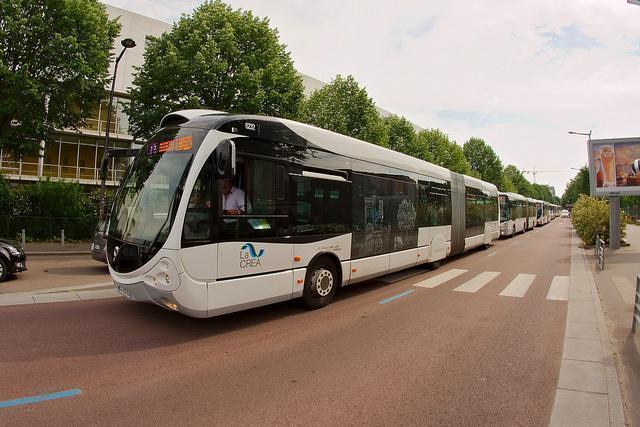What do the white markings on the road allow for here?
Answer the question by selecting the correct answer among the 4 following choices and explain your choice with a short sentence. The answer should be formatted with the following format: `Answer: choice
Rationale: rationale.`
Options: Crossing street, turning left, speeding up, turning right. Answer: crossing street.
Rationale: People are supposed to cross here. 